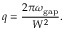Convert formula to latex. <formula><loc_0><loc_0><loc_500><loc_500>q = \frac { 2 \pi \omega _ { g a p } } { W ^ { 2 } } .</formula> 